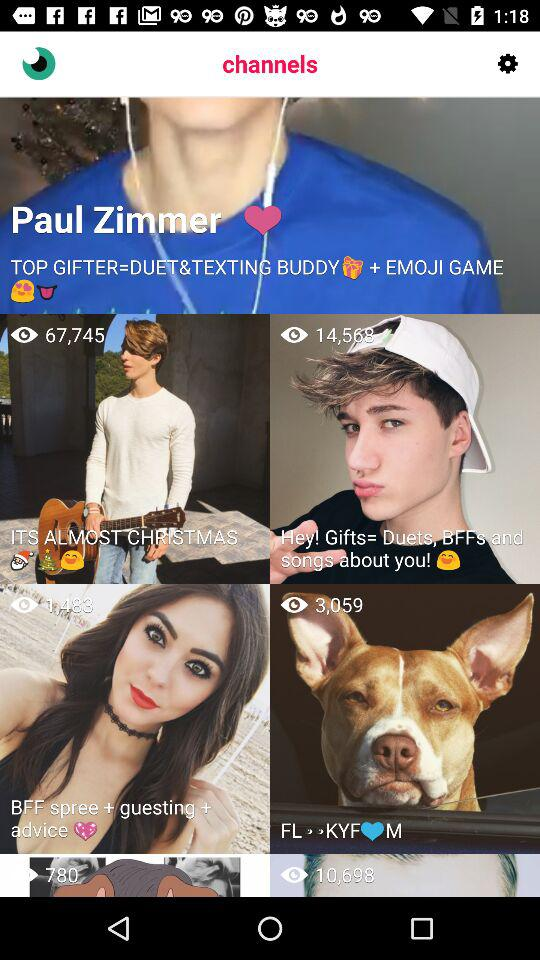How many views are there for "ITS ALMOST CHRISTMAS"? There are 67,745 views. 